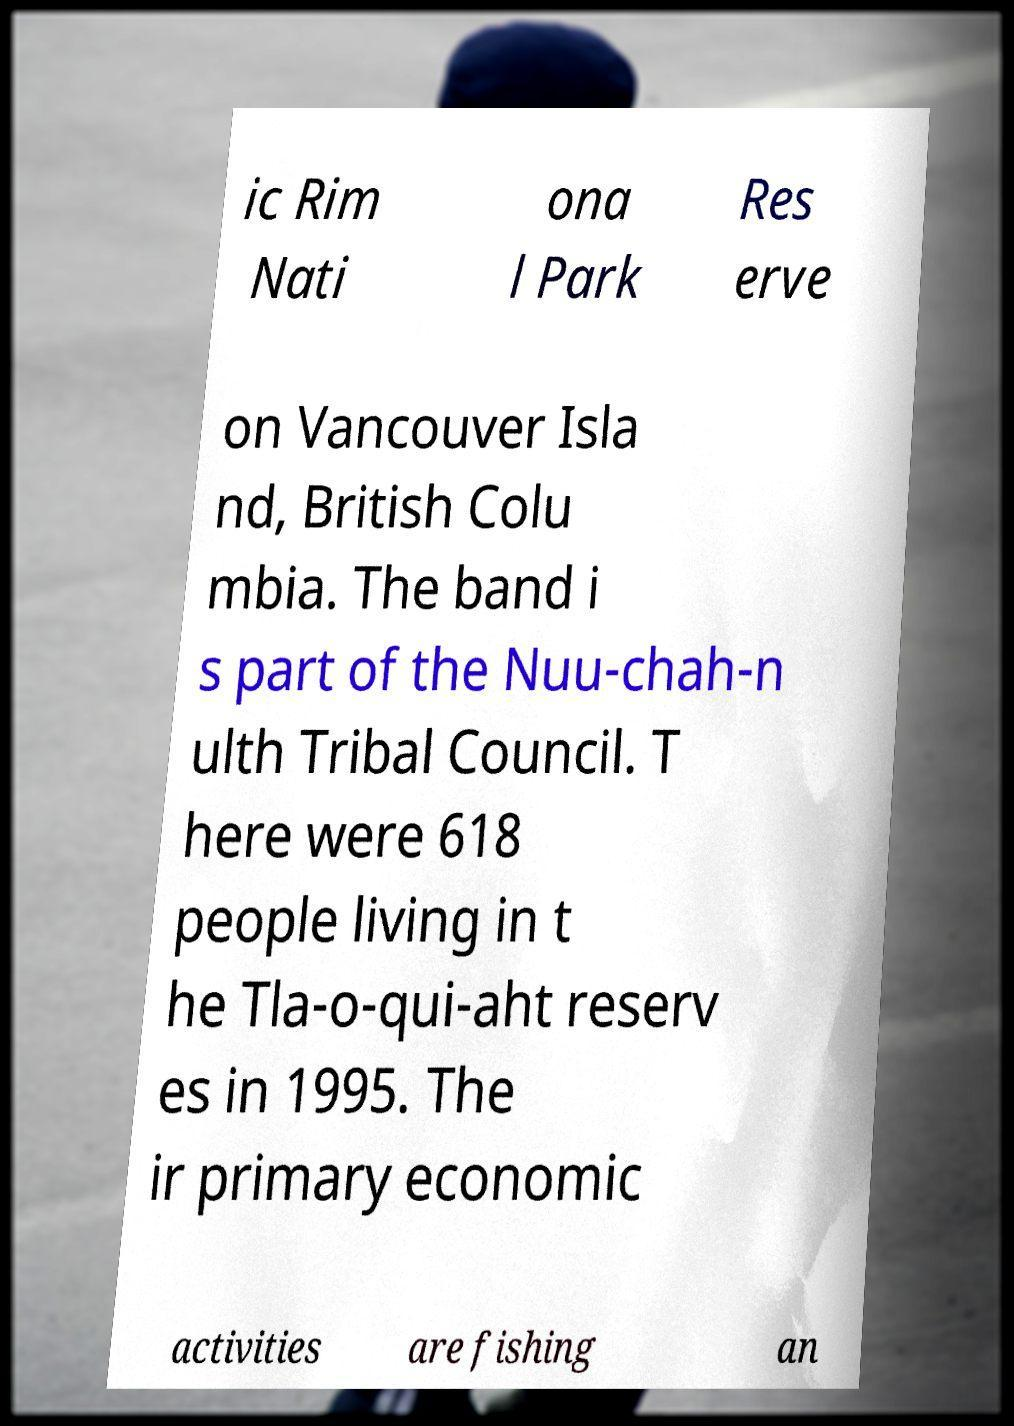For documentation purposes, I need the text within this image transcribed. Could you provide that? ic Rim Nati ona l Park Res erve on Vancouver Isla nd, British Colu mbia. The band i s part of the Nuu-chah-n ulth Tribal Council. T here were 618 people living in t he Tla-o-qui-aht reserv es in 1995. The ir primary economic activities are fishing an 